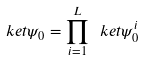<formula> <loc_0><loc_0><loc_500><loc_500>\ k e t { \psi _ { 0 } } = \prod _ { i = 1 } ^ { L } \ k e t { \psi _ { 0 } ^ { i } }</formula> 